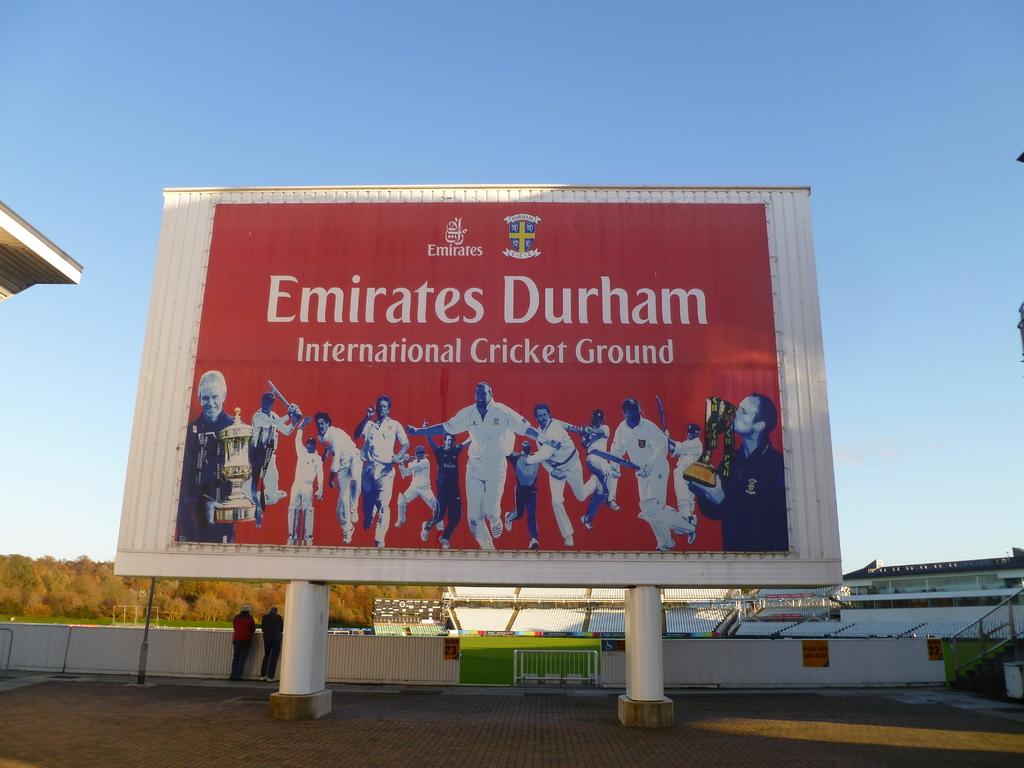What is the name of this place?
Offer a terse response. Emirates durham. Is this an international stadium?
Ensure brevity in your answer.  Yes. 